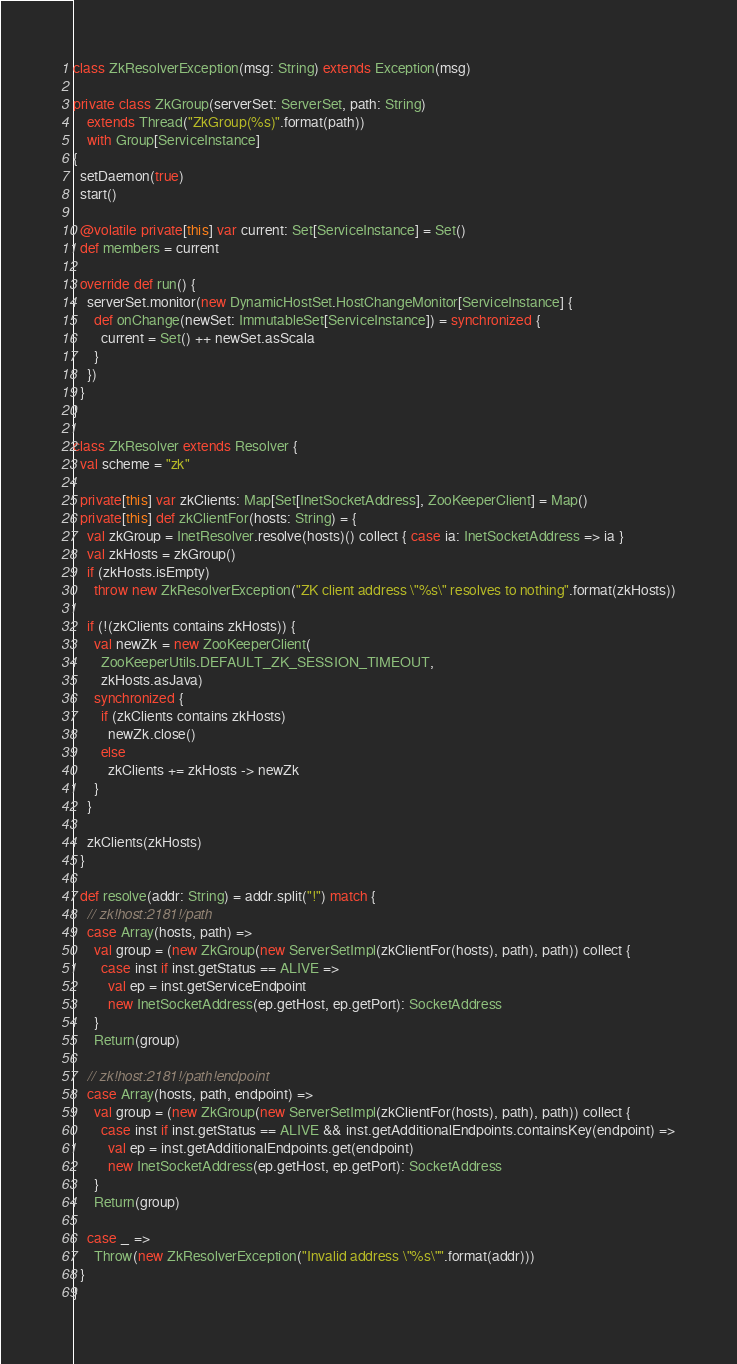Convert code to text. <code><loc_0><loc_0><loc_500><loc_500><_Scala_>
class ZkResolverException(msg: String) extends Exception(msg)

private class ZkGroup(serverSet: ServerSet, path: String)
    extends Thread("ZkGroup(%s)".format(path))
    with Group[ServiceInstance]
{
  setDaemon(true)
  start()

  @volatile private[this] var current: Set[ServiceInstance] = Set()
  def members = current

  override def run() {
    serverSet.monitor(new DynamicHostSet.HostChangeMonitor[ServiceInstance] {
      def onChange(newSet: ImmutableSet[ServiceInstance]) = synchronized {
        current = Set() ++ newSet.asScala
      }
    })
  }
}

class ZkResolver extends Resolver {
  val scheme = "zk"

  private[this] var zkClients: Map[Set[InetSocketAddress], ZooKeeperClient] = Map()
  private[this] def zkClientFor(hosts: String) = {
    val zkGroup = InetResolver.resolve(hosts)() collect { case ia: InetSocketAddress => ia }
    val zkHosts = zkGroup()
    if (zkHosts.isEmpty)
      throw new ZkResolverException("ZK client address \"%s\" resolves to nothing".format(zkHosts))

    if (!(zkClients contains zkHosts)) {
      val newZk = new ZooKeeperClient(
        ZooKeeperUtils.DEFAULT_ZK_SESSION_TIMEOUT,
        zkHosts.asJava)
      synchronized {
        if (zkClients contains zkHosts)
          newZk.close()
        else
          zkClients += zkHosts -> newZk
      }
    }

    zkClients(zkHosts)
  }

  def resolve(addr: String) = addr.split("!") match {
    // zk!host:2181!/path
    case Array(hosts, path) =>
      val group = (new ZkGroup(new ServerSetImpl(zkClientFor(hosts), path), path)) collect {
        case inst if inst.getStatus == ALIVE =>
          val ep = inst.getServiceEndpoint
          new InetSocketAddress(ep.getHost, ep.getPort): SocketAddress
      }
      Return(group)

    // zk!host:2181!/path!endpoint
    case Array(hosts, path, endpoint) =>
      val group = (new ZkGroup(new ServerSetImpl(zkClientFor(hosts), path), path)) collect {
        case inst if inst.getStatus == ALIVE && inst.getAdditionalEndpoints.containsKey(endpoint) =>
          val ep = inst.getAdditionalEndpoints.get(endpoint)
          new InetSocketAddress(ep.getHost, ep.getPort): SocketAddress
      }
      Return(group)

    case _ =>
      Throw(new ZkResolverException("Invalid address \"%s\"".format(addr)))
  }
}
</code> 